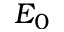<formula> <loc_0><loc_0><loc_500><loc_500>E _ { 0 }</formula> 